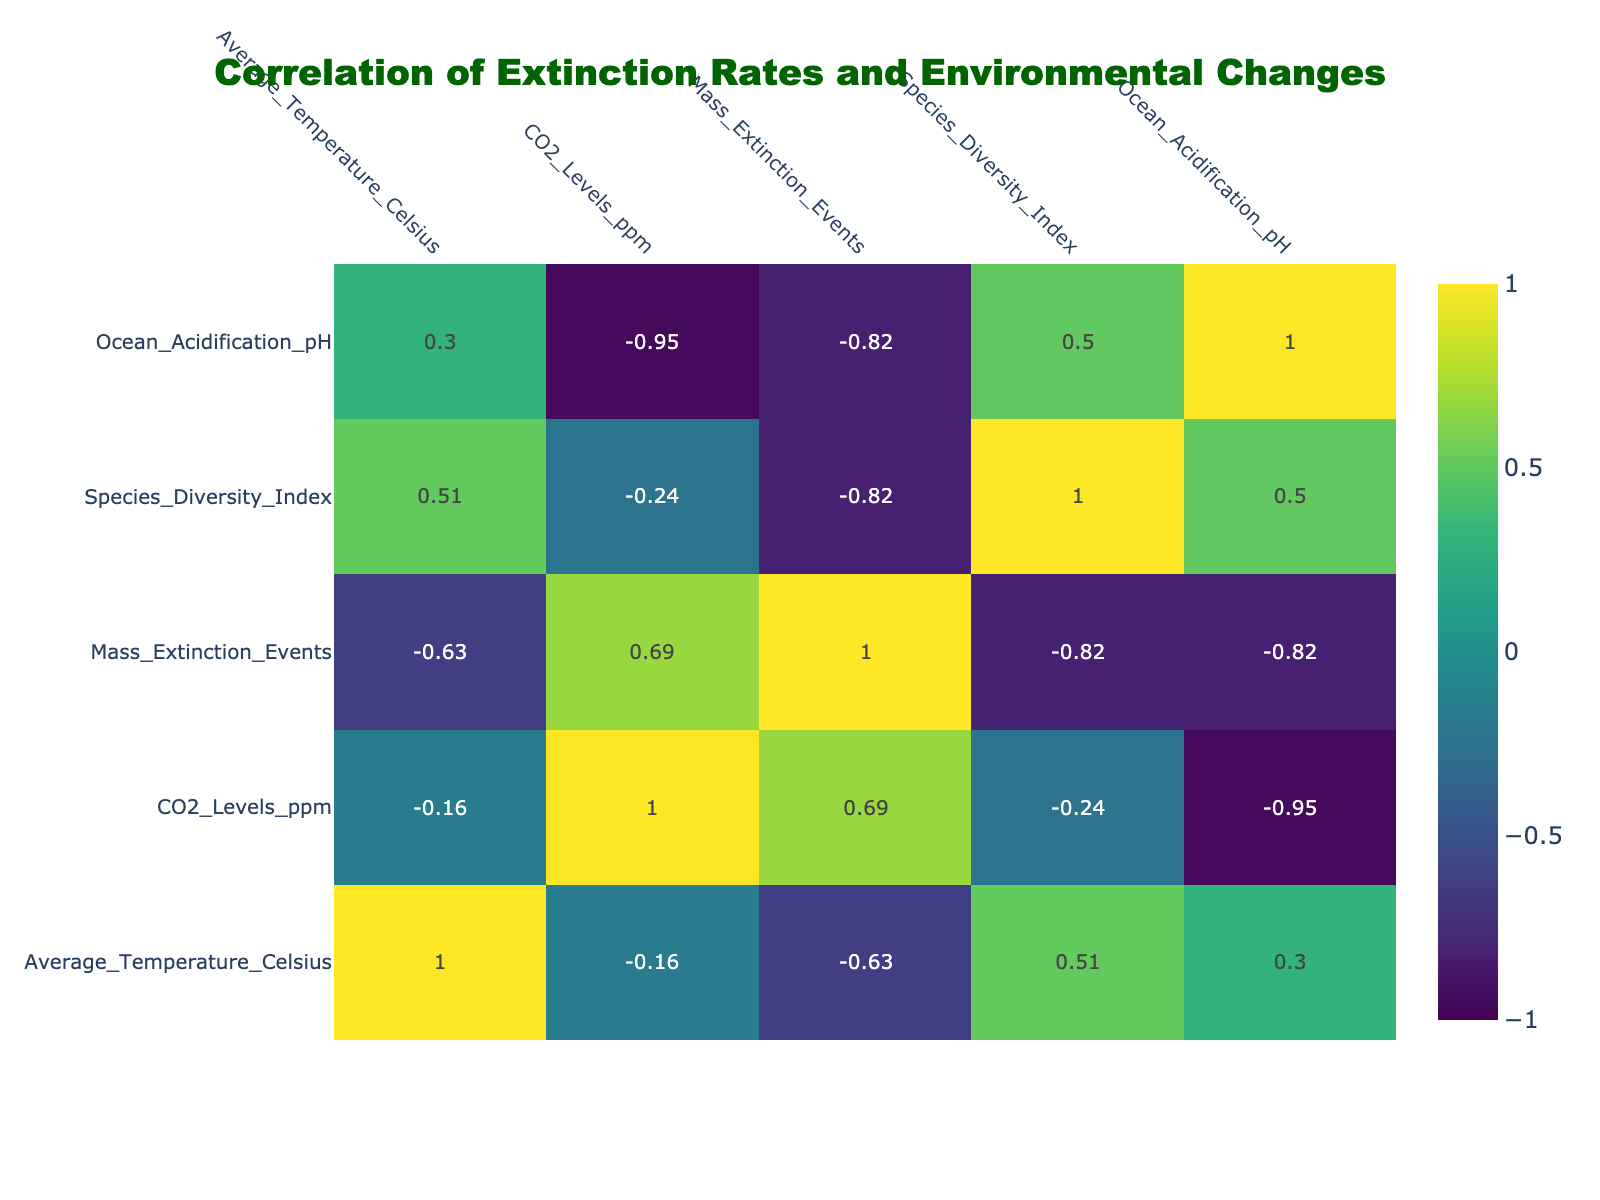What is the correlation between Average Temperature and Mass Extinction Events? Looking at the correlation table, the correlation coefficient between Average Temperature and Mass Extinction Events is approximately -0.52. This indicates a moderate negative correlation; as Average Temperature increases, the likelihood of Mass Extinction Events decreases somewhat.
Answer: -0.52 Which time period experienced the highest CO2 levels? In the table, the Triassic_Jurassic time period shows the highest CO2 levels at 1600 ppm, which is greater than any other period listed.
Answer: 1600 ppm Is there a Mass Extinction Event in the Quaternary period? Referring to the table, the Quaternary period has 0 Mass Extinction Events recorded, which indicates there was no mass extinction during this time.
Answer: No What is the average Ocean Acidification pH for the time periods that had Mass Extinction Events? The time periods with Mass Extinction Events are Permian_Triassic, Triassic_Jurassic, and Cretaceous_Paleogene. Their Ocean Acidification pH values are 7.8, 7.5, and 7.4, respectively. To find the average: (7.8 + 7.5 + 7.4) / 3 = 7.56667, rounding to 7.57.
Answer: 7.57 How does Species Diversity Index change from the Permian_Triassic to the Quaternary? By examining the table, the Species Diversity Index rises from 5 in the Permian_Triassic to 8 in the Quaternary. Thus, the index increases by 3 over this time span.
Answer: Increased by 3 What is the relationship between CO2 Levels and Ocean Acidification pH across time periods? The correlation in the table shows that CO2 Levels and Ocean Acidification pH is approximately -0.75, which indicates a strong negative correlation. This means that higher CO2 levels tend to correlate with lower pH levels, suggesting more acidic oceans.
Answer: -0.75 How many time periods had a Species Diversity Index greater than 7? Referring to the table, the time periods with a Species Diversity Index greater than 7 are Paleogene_Neogene (7) and Quaternary (8). Hence, there are two time periods that meet this criterion.
Answer: 2 Is it true that the Cretaceous_Paleogene period had the lowest Average Temperature? According to the table, the Cretaceous_Paleogene period had an Average Temperature of -5 degrees Celsius, which is indeed the lowest when comparing it to the other time periods listed.
Answer: Yes 